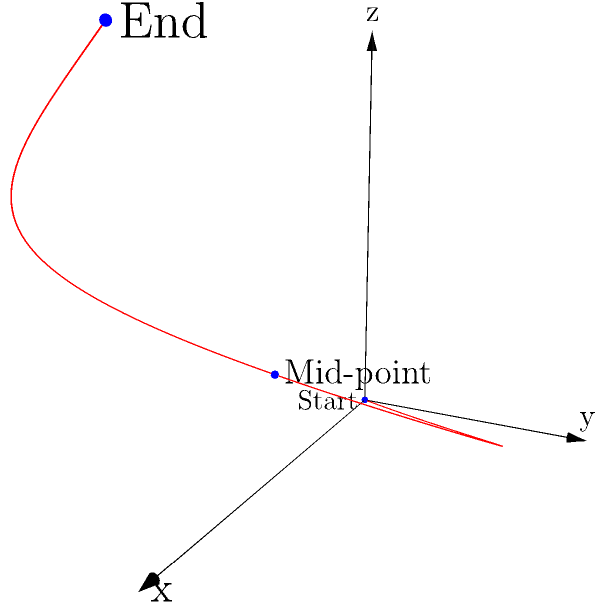As a dance competition judge, you're analyzing a dancer's leap using a 3D coordinate system. The trajectory of the leap is modeled by the function $f(t) = (2t, 3\sin(\pi t), t^2)$, where $t$ is the time parameter from 0 to 2 seconds. At what time $t$ does the dancer reach the highest point in their leap? To find the highest point of the leap, we need to analyze the y-coordinate of the function, which represents the vertical position of the dancer.

1. The y-coordinate is given by $y = 3\sin(\pi t)$.

2. To find the maximum value of this function, we need to determine when its derivative equals zero:
   $$\frac{dy}{dt} = 3\pi \cos(\pi t)$$

3. Set this equal to zero:
   $$3\pi \cos(\pi t) = 0$$
   $$\cos(\pi t) = 0$$

4. Solve for t:
   $$\pi t = \frac{\pi}{2}$$
   $$t = \frac{1}{2}$$

5. Verify this is a maximum (not a minimum) by checking the second derivative:
   $$\frac{d^2y}{dt^2} = -3\pi^2 \sin(\pi t)$$
   At $t = \frac{1}{2}$, this is negative, confirming a maximum.

6. Check that this solution is within the given time range of 0 to 2 seconds.

Therefore, the dancer reaches the highest point in their leap at $t = \frac{1}{2}$ seconds.
Answer: $\frac{1}{2}$ seconds 